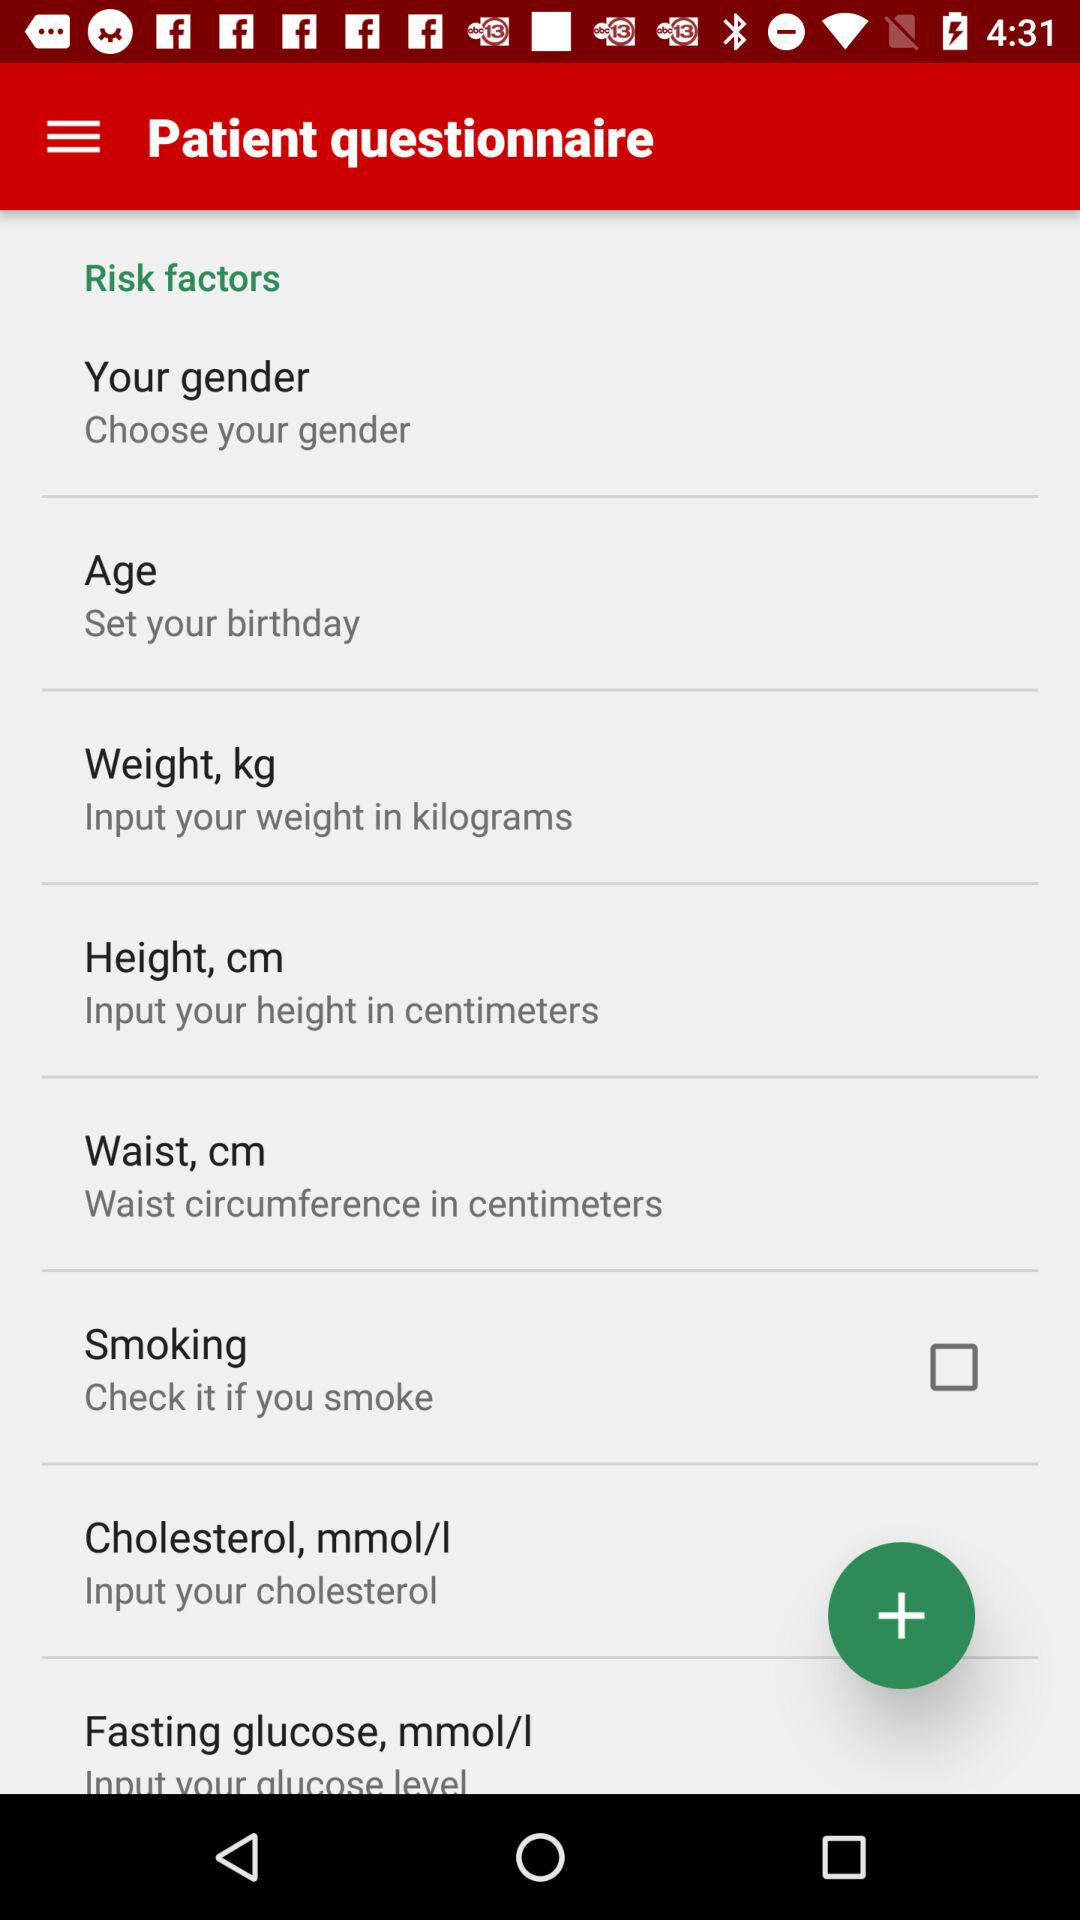What's the status of "Smoking"? The status is "off". 